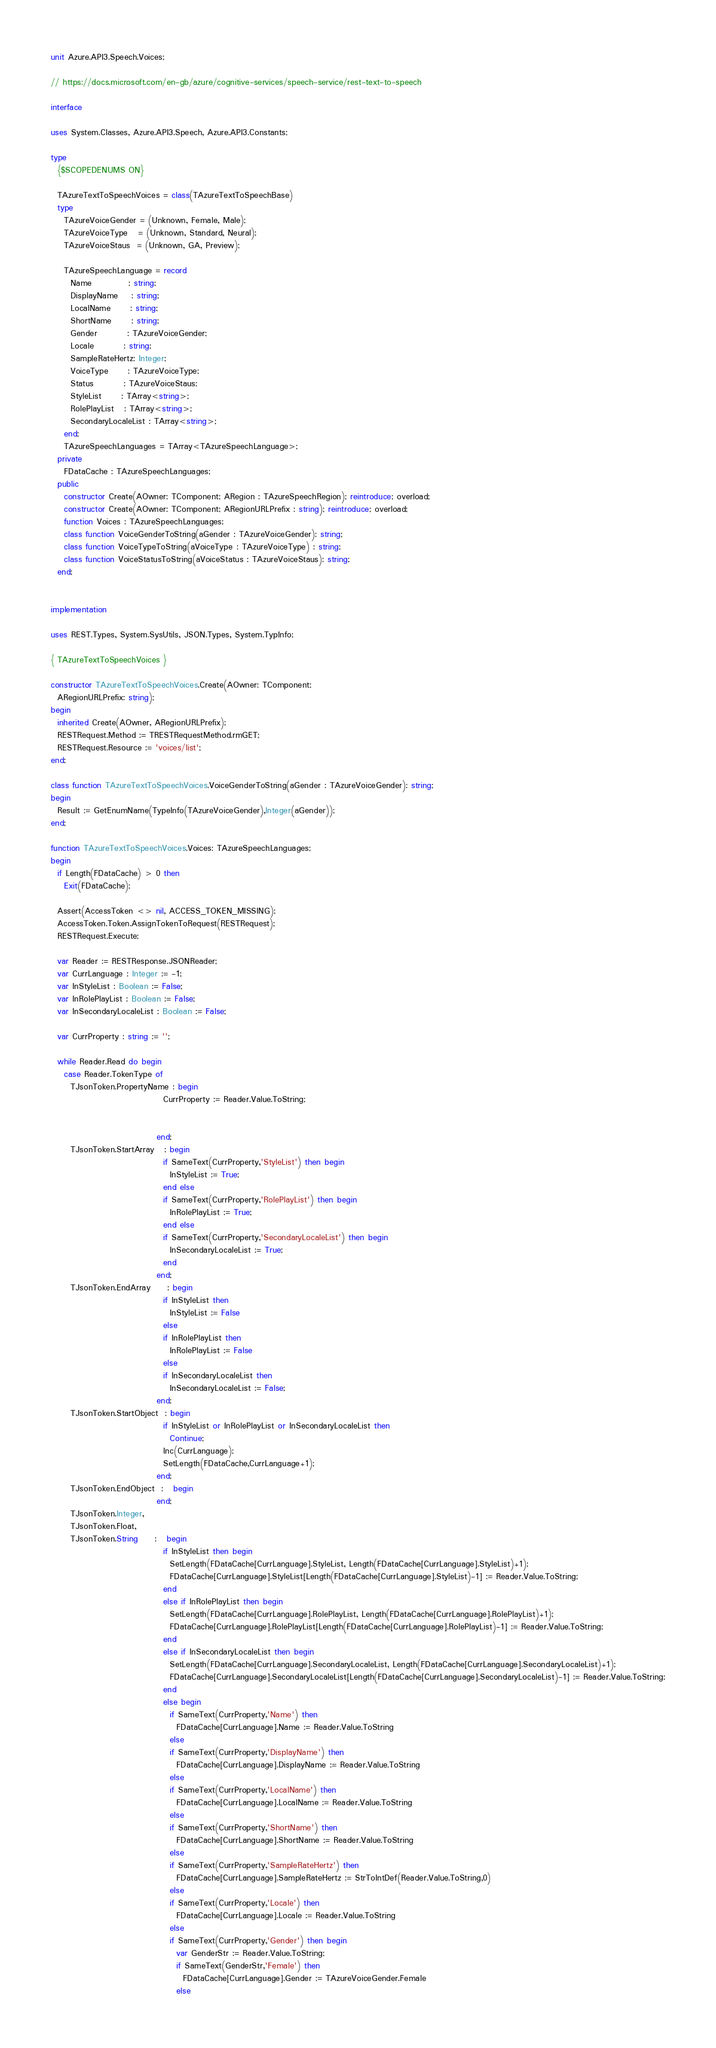Convert code to text. <code><loc_0><loc_0><loc_500><loc_500><_Pascal_>unit Azure.API3.Speech.Voices;

// https://docs.microsoft.com/en-gb/azure/cognitive-services/speech-service/rest-text-to-speech

interface

uses System.Classes, Azure.API3.Speech, Azure.API3.Constants;

type
  {$SCOPEDENUMS ON}

  TAzureTextToSpeechVoices = class(TAzureTextToSpeechBase)
  type
    TAzureVoiceGender = (Unknown, Female, Male);
    TAzureVoiceType   = (Unknown, Standard, Neural);
    TAzureVoiceStaus  = (Unknown, GA, Preview);

    TAzureSpeechLanguage = record
      Name           : string;
      DisplayName    : string;
      LocalName      : string;
      ShortName      : string;
      Gender         : TAzureVoiceGender;
      Locale         : string;
      SampleRateHertz: Integer;
      VoiceType      : TAzureVoiceType;
      Status         : TAzureVoiceStaus;
      StyleList      : TArray<string>;
      RolePlayList   : TArray<string>;
      SecondaryLocaleList : TArray<string>;
    end;
    TAzureSpeechLanguages = TArray<TAzureSpeechLanguage>;
  private
    FDataCache : TAzureSpeechLanguages;
  public
    constructor Create(AOwner: TComponent; ARegion : TAzureSpeechRegion); reintroduce; overload;
    constructor Create(AOwner: TComponent; ARegionURLPrefix : string); reintroduce; overload;
    function Voices : TAzureSpeechLanguages;
    class function VoiceGenderToString(aGender : TAzureVoiceGender): string;
    class function VoiceTypeToString(aVoiceType : TAzureVoiceType) : string;
    class function VoiceStatusToString(aVoiceStatus : TAzureVoiceStaus): string;
  end;


implementation

uses REST.Types, System.SysUtils, JSON.Types, System.TypInfo;

{ TAzureTextToSpeechVoices }

constructor TAzureTextToSpeechVoices.Create(AOwner: TComponent;
  ARegionURLPrefix: string);
begin
  inherited Create(AOwner, ARegionURLPrefix);
  RESTRequest.Method := TRESTRequestMethod.rmGET;
  RESTRequest.Resource := 'voices/list';
end;

class function TAzureTextToSpeechVoices.VoiceGenderToString(aGender : TAzureVoiceGender): string;
begin
  Result := GetEnumName(TypeInfo(TAzureVoiceGender),Integer(aGender));
end;

function TAzureTextToSpeechVoices.Voices: TAzureSpeechLanguages;
begin
  if Length(FDataCache) > 0 then
    Exit(FDataCache);

  Assert(AccessToken <> nil, ACCESS_TOKEN_MISSING);
  AccessToken.Token.AssignTokenToRequest(RESTRequest);
  RESTRequest.Execute;

  var Reader := RESTResponse.JSONReader;
  var CurrLanguage : Integer := -1;
  var InStyleList : Boolean := False;
  var InRolePlayList : Boolean := False;
  var InSecondaryLocaleList : Boolean := False;

  var CurrProperty : string := '';

  while Reader.Read do begin
    case Reader.TokenType of
      TJsonToken.PropertyName : begin
                                  CurrProperty := Reader.Value.ToString;


                                end;
      TJsonToken.StartArray   : begin
                                  if SameText(CurrProperty,'StyleList') then begin
                                    InStyleList := True;
                                  end else
                                  if SameText(CurrProperty,'RolePlayList') then begin
                                    InRolePlayList := True;
                                  end else
                                  if SameText(CurrProperty,'SecondaryLocaleList') then begin
                                    InSecondaryLocaleList := True;
                                  end
                                end;
      TJsonToken.EndArray     : begin
                                  if InStyleList then
                                    InStyleList := False
                                  else
                                  if InRolePlayList then
                                    InRolePlayList := False
                                  else
                                  if InSecondaryLocaleList then
                                    InSecondaryLocaleList := False;
                                end;
      TJsonToken.StartObject  : begin
                                  if InStyleList or InRolePlayList or InSecondaryLocaleList then
                                    Continue;
                                  Inc(CurrLanguage);
                                  SetLength(FDataCache,CurrLanguage+1);
                                end;
      TJsonToken.EndObject  :   begin
                                end;
      TJsonToken.Integer,
      TJsonToken.Float,
      TJsonToken.String     :   begin
                                  if InStyleList then begin
                                    SetLength(FDataCache[CurrLanguage].StyleList, Length(FDataCache[CurrLanguage].StyleList)+1);
                                    FDataCache[CurrLanguage].StyleList[Length(FDataCache[CurrLanguage].StyleList)-1] := Reader.Value.ToString;
                                  end
                                  else if InRolePlayList then begin
                                    SetLength(FDataCache[CurrLanguage].RolePlayList, Length(FDataCache[CurrLanguage].RolePlayList)+1);
                                    FDataCache[CurrLanguage].RolePlayList[Length(FDataCache[CurrLanguage].RolePlayList)-1] := Reader.Value.ToString;
                                  end
                                  else if InSecondaryLocaleList then begin
                                    SetLength(FDataCache[CurrLanguage].SecondaryLocaleList, Length(FDataCache[CurrLanguage].SecondaryLocaleList)+1);
                                    FDataCache[CurrLanguage].SecondaryLocaleList[Length(FDataCache[CurrLanguage].SecondaryLocaleList)-1] := Reader.Value.ToString;
                                  end
                                  else begin
                                    if SameText(CurrProperty,'Name') then
                                      FDataCache[CurrLanguage].Name := Reader.Value.ToString
                                    else
                                    if SameText(CurrProperty,'DisplayName') then
                                      FDataCache[CurrLanguage].DisplayName := Reader.Value.ToString
                                    else
                                    if SameText(CurrProperty,'LocalName') then
                                      FDataCache[CurrLanguage].LocalName := Reader.Value.ToString
                                    else
                                    if SameText(CurrProperty,'ShortName') then
                                      FDataCache[CurrLanguage].ShortName := Reader.Value.ToString
                                    else
                                    if SameText(CurrProperty,'SampleRateHertz') then
                                      FDataCache[CurrLanguage].SampleRateHertz := StrToIntDef(Reader.Value.ToString,0)
                                    else
                                    if SameText(CurrProperty,'Locale') then
                                      FDataCache[CurrLanguage].Locale := Reader.Value.ToString
                                    else
                                    if SameText(CurrProperty,'Gender') then begin
                                      var GenderStr := Reader.Value.ToString;
                                      if SameText(GenderStr,'Female') then
                                        FDataCache[CurrLanguage].Gender := TAzureVoiceGender.Female
                                      else</code> 